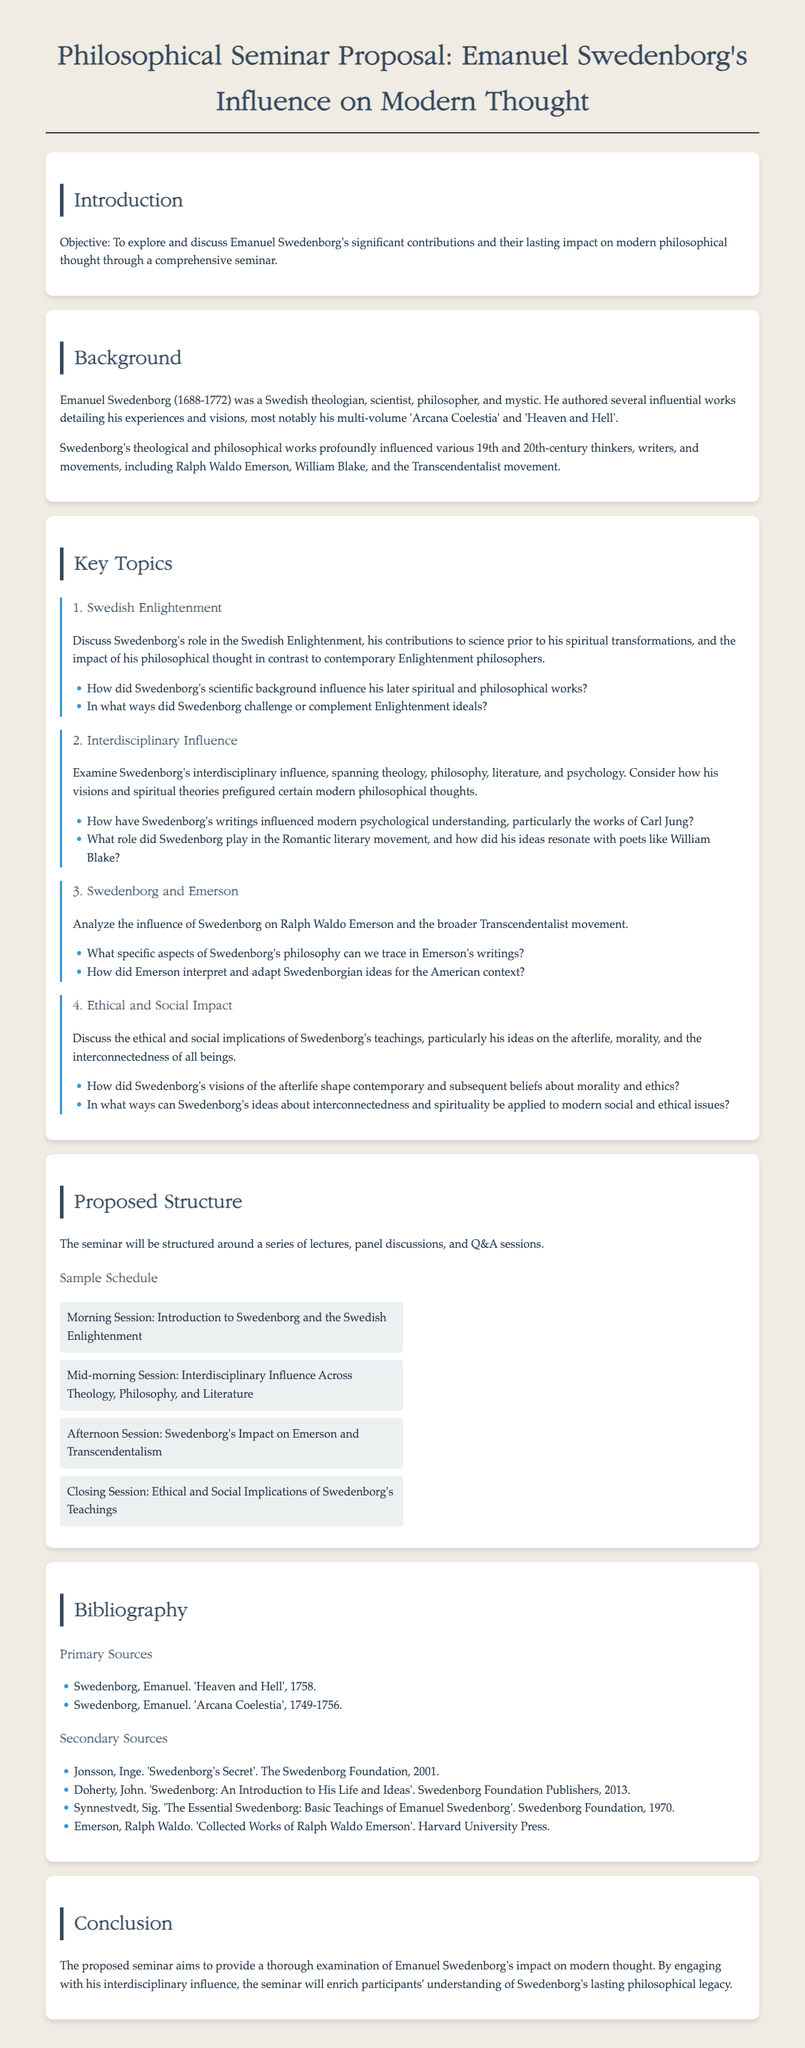What is the main objective of the seminar? The seminar aims to explore and discuss Emanuel Swedenborg's significant contributions and their lasting impact on modern philosophical thought.
Answer: To explore and discuss Emanuel Swedenborg's significant contributions and their lasting impact on modern philosophical thought Who was Emanuel Swedenborg? Swedenborg was a Swedish theologian, scientist, philosopher, and mystic known for his influential works.
Answer: A Swedish theologian, scientist, philosopher, and mystic What are two of Swedenborg's notable works? The document mentions 'Arcana Coelestia' and 'Heaven and Hell' as his notable works.
Answer: 'Arcana Coelestia' and 'Heaven and Hell' Which philosophical movement was influenced by Swedenborg's ideas? The Transcendentalist movement is specifically mentioned as being influenced by Swedenborg.
Answer: The Transcendentalist movement What specific topic addresses Swedenborg's ethical implications? The document discusses ethical and social implications under the topic "Ethical and Social Impact."
Answer: Ethical and Social Impact What format will the seminar follow? The seminar will be structured around lectures, panel discussions, and Q&A sessions.
Answer: Lectures, panel discussions, and Q&A sessions How many key topics are proposed for discussion in the seminar? The document outlines four key topics for discussion in the seminar.
Answer: Four Who wrote 'Collected Works of Ralph Waldo Emerson'? Ralph Waldo Emerson is credited with writing 'Collected Works of Ralph Waldo Emerson' in the bibliography.
Answer: Ralph Waldo Emerson 